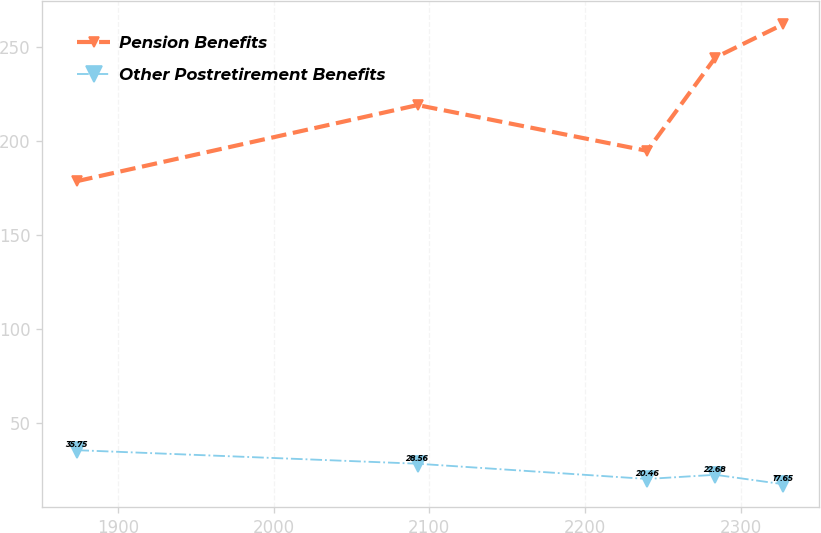Convert chart to OTSL. <chart><loc_0><loc_0><loc_500><loc_500><line_chart><ecel><fcel>Pension Benefits<fcel>Other Postretirement Benefits<nl><fcel>1873.96<fcel>178.78<fcel>35.75<nl><fcel>2092.52<fcel>219.18<fcel>28.56<nl><fcel>2239.99<fcel>194.85<fcel>20.46<nl><fcel>2283.75<fcel>244.42<fcel>22.68<nl><fcel>2327.51<fcel>262.19<fcel>17.65<nl></chart> 